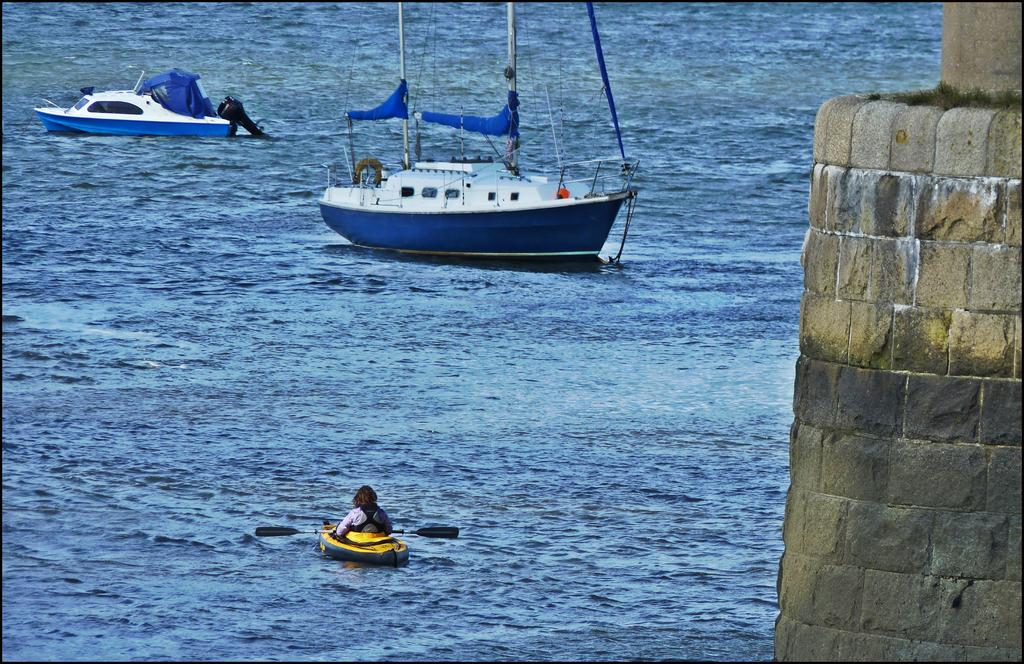What types of watercraft are present in the image? There are two boats and a ship in the image. What are the boats and ship doing in the image? The boats and ship are sailing on the water surface. What else can be seen in the image besides the watercraft? There is a tower made of bricks in the image. What type of oatmeal is being served on the ship in the image? There is no oatmeal present in the image, and the image does not depict any food being served. 